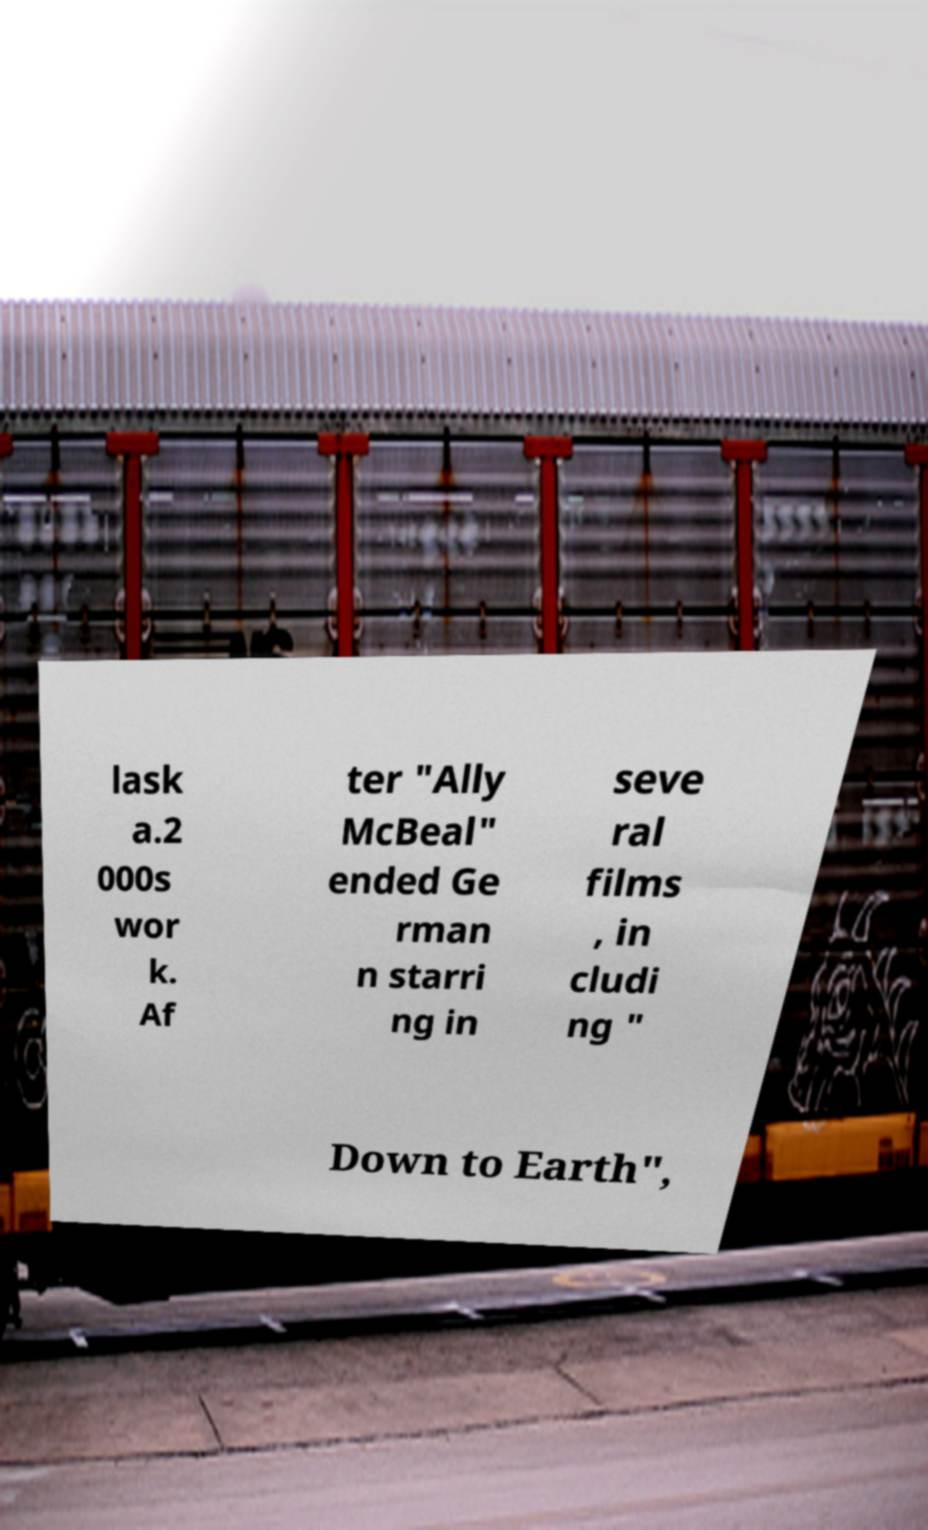Could you extract and type out the text from this image? lask a.2 000s wor k. Af ter "Ally McBeal" ended Ge rman n starri ng in seve ral films , in cludi ng " Down to Earth", 